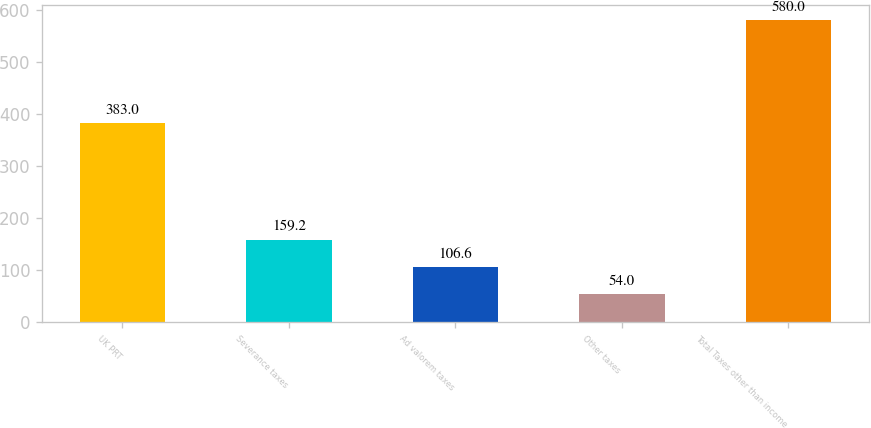<chart> <loc_0><loc_0><loc_500><loc_500><bar_chart><fcel>UK PRT<fcel>Severance taxes<fcel>Ad valorem taxes<fcel>Other taxes<fcel>Total Taxes other than income<nl><fcel>383<fcel>159.2<fcel>106.6<fcel>54<fcel>580<nl></chart> 